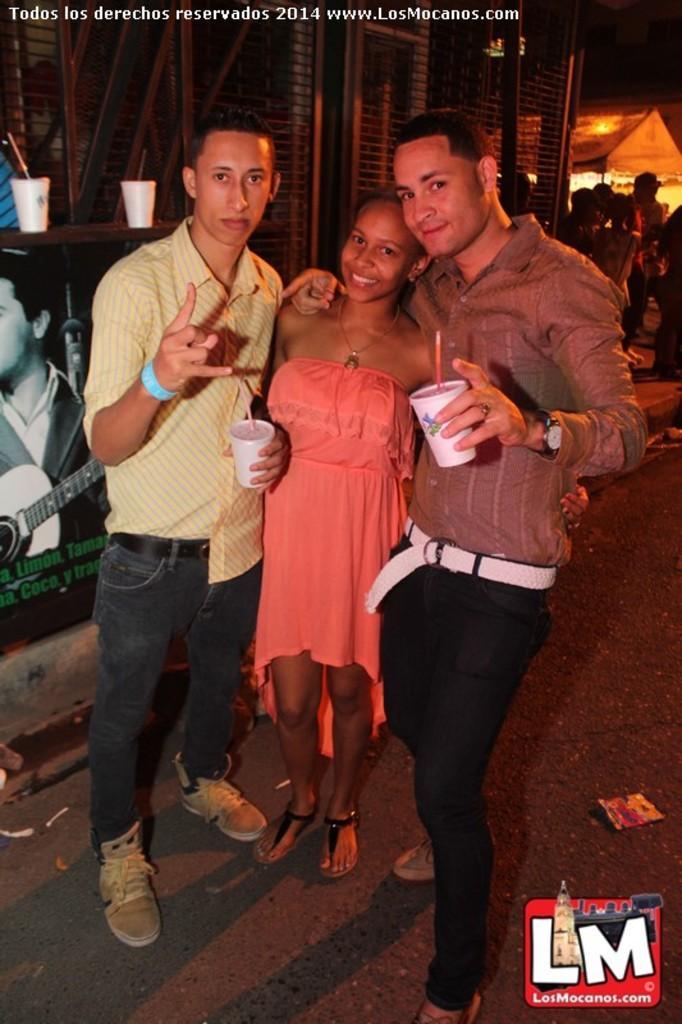Can you describe this image briefly? In the foreground of this image, there are two men and a woman standing and posing to the camera. Those two men are holding cups in their hand. In the background, there are two cups, a building, poster, persons standing, a tent and the dark sky. 